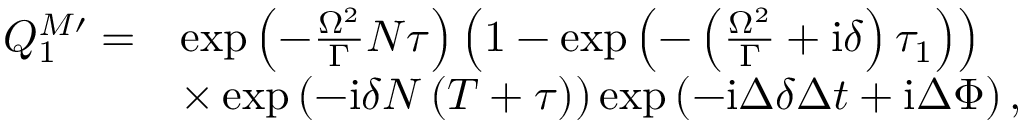Convert formula to latex. <formula><loc_0><loc_0><loc_500><loc_500>\begin{array} { r l } { Q _ { 1 } ^ { M \prime } = } & { \exp \left ( - \frac { \Omega ^ { 2 } } { \Gamma } N \tau \right ) \left ( 1 - \exp \left ( - \left ( \frac { \Omega ^ { 2 } } { \Gamma } + i \delta \right ) \tau _ { 1 } \right ) \right ) } \\ & { \times \exp \left ( - i \delta N \left ( T + \tau \right ) \right ) \exp \left ( - i \Delta \delta \Delta t + i \Delta \Phi \right ) , } \end{array}</formula> 